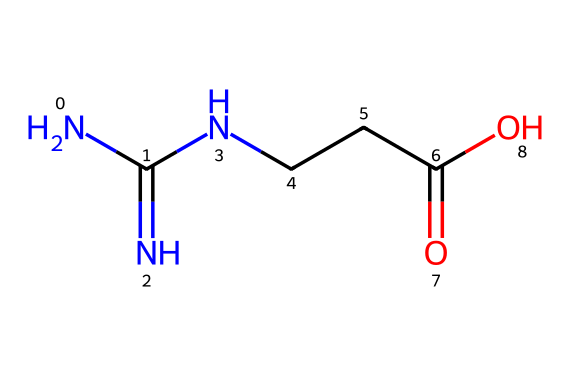What is the molecular formula of this chemical? The SMILES representation of this chemical is NC(=N)NCCC(=O)O. By analyzing the elements present in the structure, we can determine that there are 4 carbon atoms, 8 hydrogen atoms, 4 nitrogen atoms, and 2 oxygen atoms, leading to the molecular formula C4H9N3O2.
Answer: C4H9N3O2 How many nitrogen atoms are in the structure? By examining the SMILES representation, we can see there are three instances of 'N', indicating three nitrogen atoms present in the chemical structure.
Answer: three What type of functional groups are present in this compound? The structure has a carboxylic acid group, as indicated by the presence of the -COOH group in the molecule, and an amine group due to the -NH2 portion of the structure.
Answer: carboxylic acid and amine What is the primary use of creatine? Creatine is primarily used as a supplement to enhance athletic performance by improving strength and increasing muscle mass.
Answer: improve athletic performance Does this molecule contain any double bonds? The structural formula includes a double bond represented by C(=O) in the carboxylic acid group and C(=N) in the guanidine portion; hence it does contain double bonds.
Answer: yes What is the charge of this molecule at physiological pH? At physiological pH (around 7.4), the carboxylic acid group tends to lose a proton (H+), and the amine may be protonated, making the overall charge neutral, as the positive and negative charges balance out.
Answer: neutral What type of compound is creatine classified as? Given the presence of nitrogen and the specific structure, creatine is classified as an amino acid derivative, specifically a guanidine, used in muscle metabolism.
Answer: amino acid derivative 